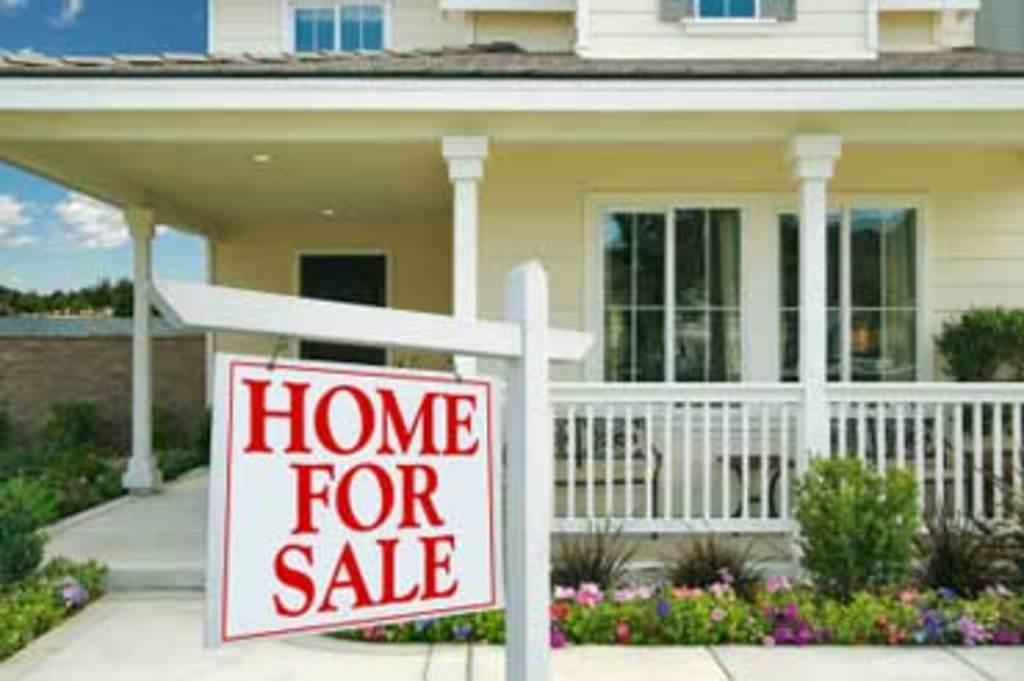Please provide a concise description of this image. In this image we can see a building. In front of the building we can see plants, flowers, bench and a board attached to a wooden object. On the board we can see the text. On the left side, we can see the wall, trees and plants. In the top left, we can see the sky. 